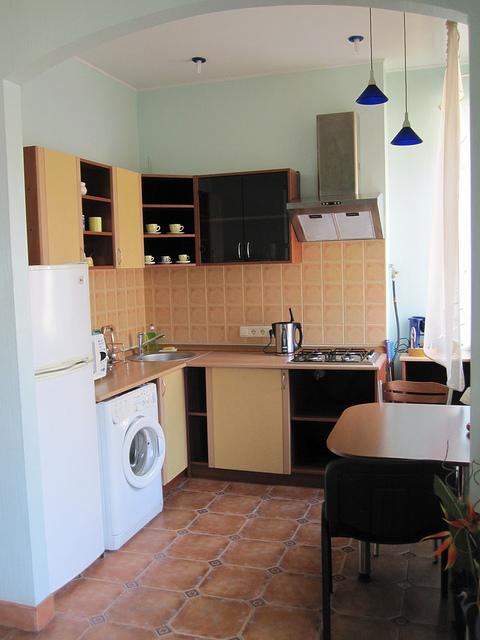Is there a cell phone on the table?
Give a very brief answer. No. How is the eating area constructed differently than the rest of the kitchen?
Quick response, please. Smaller. Is the decor modern?
Answer briefly. Yes. Is the table empty?
Short answer required. Yes. Are the appliances made with stainless steel?
Give a very brief answer. No. Is there a washer in this room?
Keep it brief. Yes. What kind of room is this?
Answer briefly. Kitchen. What type of material is the refrigerator made of?
Quick response, please. Metal. What color are the hanging lights?
Short answer required. Blue. What time is it?
Concise answer only. Noon. What is in the toaster?
Concise answer only. Bread. Is the wood shown mahogany?
Concise answer only. No. What can you do in this room?
Quick response, please. Cook. What shape do the brown tiles make on the floor?
Short answer required. Square. 